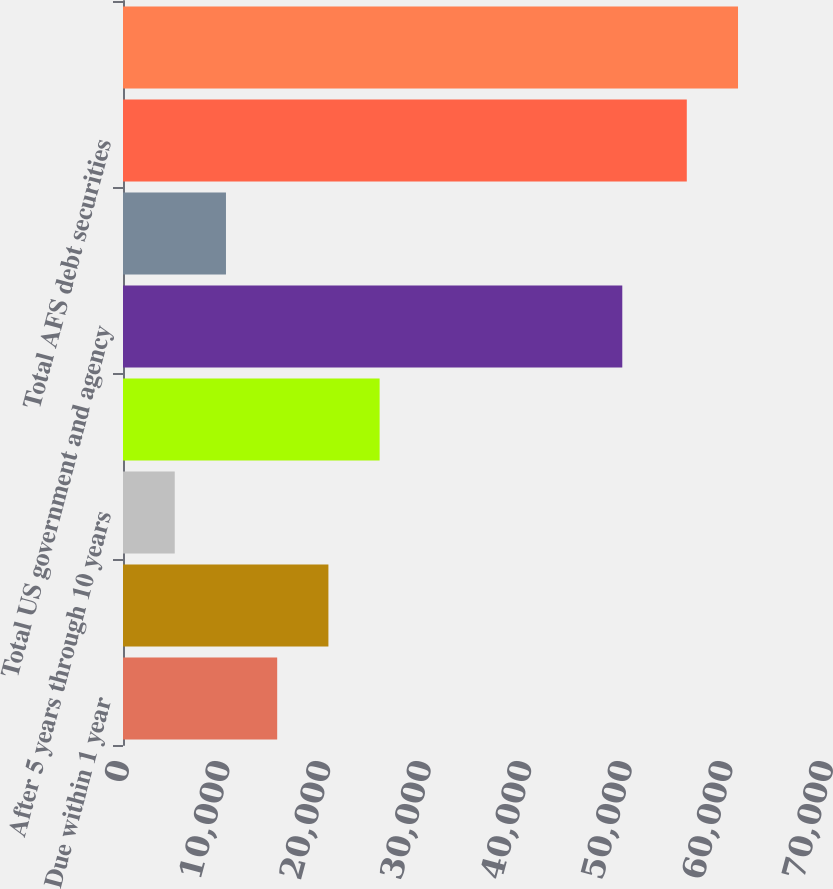Convert chart to OTSL. <chart><loc_0><loc_0><loc_500><loc_500><bar_chart><fcel>Due within 1 year<fcel>After 1 year through 5 years<fcel>After 5 years through 10 years<fcel>After 10 years<fcel>Total US government and agency<fcel>Total corporate and other debt<fcel>Total AFS debt securities<fcel>Total AFS securities<nl><fcel>15331.6<fcel>20424.4<fcel>5146<fcel>25517.2<fcel>49645<fcel>10238.8<fcel>56059<fcel>61151.8<nl></chart> 